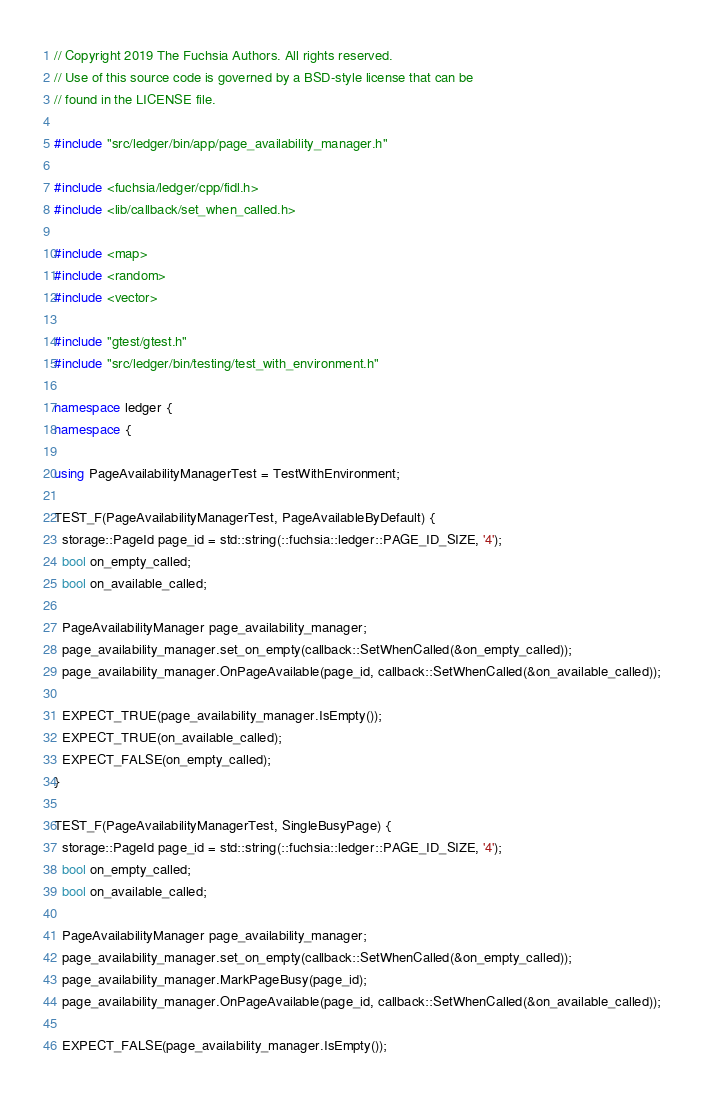Convert code to text. <code><loc_0><loc_0><loc_500><loc_500><_C++_>// Copyright 2019 The Fuchsia Authors. All rights reserved.
// Use of this source code is governed by a BSD-style license that can be
// found in the LICENSE file.

#include "src/ledger/bin/app/page_availability_manager.h"

#include <fuchsia/ledger/cpp/fidl.h>
#include <lib/callback/set_when_called.h>

#include <map>
#include <random>
#include <vector>

#include "gtest/gtest.h"
#include "src/ledger/bin/testing/test_with_environment.h"

namespace ledger {
namespace {

using PageAvailabilityManagerTest = TestWithEnvironment;

TEST_F(PageAvailabilityManagerTest, PageAvailableByDefault) {
  storage::PageId page_id = std::string(::fuchsia::ledger::PAGE_ID_SIZE, '4');
  bool on_empty_called;
  bool on_available_called;

  PageAvailabilityManager page_availability_manager;
  page_availability_manager.set_on_empty(callback::SetWhenCalled(&on_empty_called));
  page_availability_manager.OnPageAvailable(page_id, callback::SetWhenCalled(&on_available_called));

  EXPECT_TRUE(page_availability_manager.IsEmpty());
  EXPECT_TRUE(on_available_called);
  EXPECT_FALSE(on_empty_called);
}

TEST_F(PageAvailabilityManagerTest, SingleBusyPage) {
  storage::PageId page_id = std::string(::fuchsia::ledger::PAGE_ID_SIZE, '4');
  bool on_empty_called;
  bool on_available_called;

  PageAvailabilityManager page_availability_manager;
  page_availability_manager.set_on_empty(callback::SetWhenCalled(&on_empty_called));
  page_availability_manager.MarkPageBusy(page_id);
  page_availability_manager.OnPageAvailable(page_id, callback::SetWhenCalled(&on_available_called));

  EXPECT_FALSE(page_availability_manager.IsEmpty());</code> 